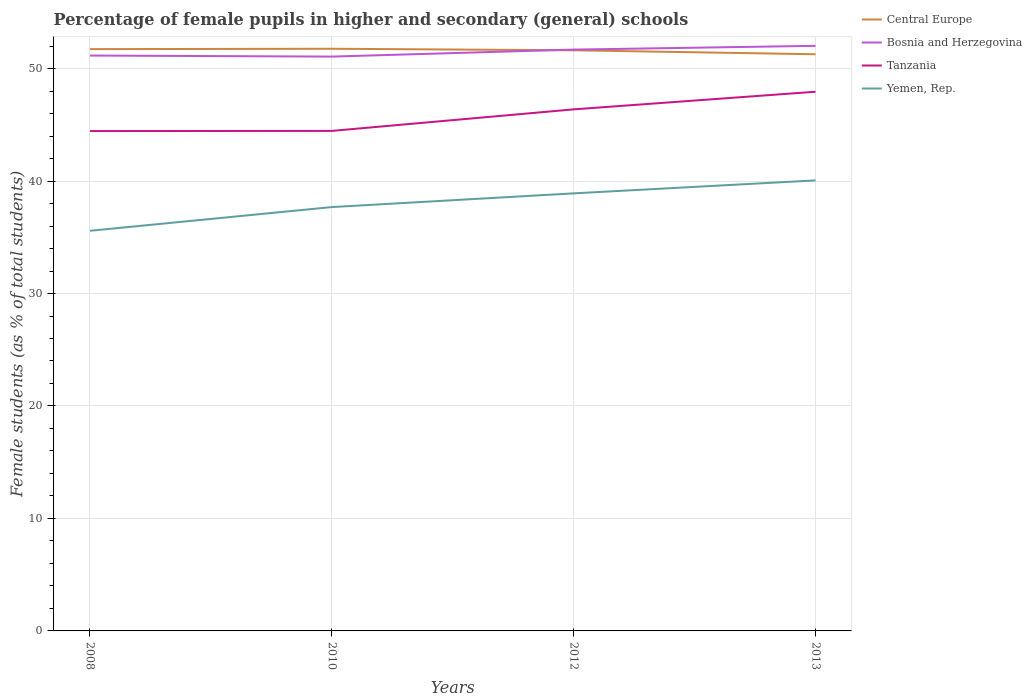How many different coloured lines are there?
Provide a short and direct response. 4. Across all years, what is the maximum percentage of female pupils in higher and secondary schools in Yemen, Rep.?
Give a very brief answer. 35.58. In which year was the percentage of female pupils in higher and secondary schools in Central Europe maximum?
Ensure brevity in your answer.  2013. What is the total percentage of female pupils in higher and secondary schools in Tanzania in the graph?
Your response must be concise. -0.01. What is the difference between the highest and the second highest percentage of female pupils in higher and secondary schools in Central Europe?
Offer a terse response. 0.49. What is the difference between the highest and the lowest percentage of female pupils in higher and secondary schools in Yemen, Rep.?
Provide a succinct answer. 2. Is the percentage of female pupils in higher and secondary schools in Bosnia and Herzegovina strictly greater than the percentage of female pupils in higher and secondary schools in Central Europe over the years?
Keep it short and to the point. No. How many years are there in the graph?
Keep it short and to the point. 4. Does the graph contain any zero values?
Your response must be concise. No. Where does the legend appear in the graph?
Your response must be concise. Top right. How are the legend labels stacked?
Offer a very short reply. Vertical. What is the title of the graph?
Keep it short and to the point. Percentage of female pupils in higher and secondary (general) schools. Does "Mali" appear as one of the legend labels in the graph?
Your response must be concise. No. What is the label or title of the Y-axis?
Your answer should be very brief. Female students (as % of total students). What is the Female students (as % of total students) of Central Europe in 2008?
Give a very brief answer. 51.73. What is the Female students (as % of total students) in Bosnia and Herzegovina in 2008?
Your answer should be very brief. 51.16. What is the Female students (as % of total students) of Tanzania in 2008?
Provide a short and direct response. 44.44. What is the Female students (as % of total students) in Yemen, Rep. in 2008?
Give a very brief answer. 35.58. What is the Female students (as % of total students) in Central Europe in 2010?
Ensure brevity in your answer.  51.76. What is the Female students (as % of total students) of Bosnia and Herzegovina in 2010?
Provide a short and direct response. 51.06. What is the Female students (as % of total students) of Tanzania in 2010?
Your answer should be compact. 44.46. What is the Female students (as % of total students) in Yemen, Rep. in 2010?
Your answer should be compact. 37.69. What is the Female students (as % of total students) in Central Europe in 2012?
Your answer should be very brief. 51.63. What is the Female students (as % of total students) in Bosnia and Herzegovina in 2012?
Ensure brevity in your answer.  51.69. What is the Female students (as % of total students) in Tanzania in 2012?
Offer a terse response. 46.37. What is the Female students (as % of total students) of Yemen, Rep. in 2012?
Provide a short and direct response. 38.9. What is the Female students (as % of total students) in Central Europe in 2013?
Ensure brevity in your answer.  51.27. What is the Female students (as % of total students) of Bosnia and Herzegovina in 2013?
Your answer should be compact. 52.02. What is the Female students (as % of total students) in Tanzania in 2013?
Keep it short and to the point. 47.94. What is the Female students (as % of total students) in Yemen, Rep. in 2013?
Your answer should be very brief. 40.06. Across all years, what is the maximum Female students (as % of total students) in Central Europe?
Your answer should be compact. 51.76. Across all years, what is the maximum Female students (as % of total students) of Bosnia and Herzegovina?
Provide a short and direct response. 52.02. Across all years, what is the maximum Female students (as % of total students) in Tanzania?
Your response must be concise. 47.94. Across all years, what is the maximum Female students (as % of total students) of Yemen, Rep.?
Provide a succinct answer. 40.06. Across all years, what is the minimum Female students (as % of total students) of Central Europe?
Provide a succinct answer. 51.27. Across all years, what is the minimum Female students (as % of total students) in Bosnia and Herzegovina?
Make the answer very short. 51.06. Across all years, what is the minimum Female students (as % of total students) of Tanzania?
Ensure brevity in your answer.  44.44. Across all years, what is the minimum Female students (as % of total students) in Yemen, Rep.?
Offer a very short reply. 35.58. What is the total Female students (as % of total students) of Central Europe in the graph?
Ensure brevity in your answer.  206.39. What is the total Female students (as % of total students) of Bosnia and Herzegovina in the graph?
Ensure brevity in your answer.  205.93. What is the total Female students (as % of total students) of Tanzania in the graph?
Your answer should be compact. 183.21. What is the total Female students (as % of total students) in Yemen, Rep. in the graph?
Make the answer very short. 152.22. What is the difference between the Female students (as % of total students) in Central Europe in 2008 and that in 2010?
Make the answer very short. -0.03. What is the difference between the Female students (as % of total students) of Bosnia and Herzegovina in 2008 and that in 2010?
Offer a terse response. 0.09. What is the difference between the Female students (as % of total students) of Tanzania in 2008 and that in 2010?
Make the answer very short. -0.01. What is the difference between the Female students (as % of total students) in Yemen, Rep. in 2008 and that in 2010?
Make the answer very short. -2.11. What is the difference between the Female students (as % of total students) in Central Europe in 2008 and that in 2012?
Keep it short and to the point. 0.1. What is the difference between the Female students (as % of total students) of Bosnia and Herzegovina in 2008 and that in 2012?
Give a very brief answer. -0.53. What is the difference between the Female students (as % of total students) in Tanzania in 2008 and that in 2012?
Offer a very short reply. -1.93. What is the difference between the Female students (as % of total students) in Yemen, Rep. in 2008 and that in 2012?
Offer a very short reply. -3.33. What is the difference between the Female students (as % of total students) of Central Europe in 2008 and that in 2013?
Your answer should be compact. 0.46. What is the difference between the Female students (as % of total students) of Bosnia and Herzegovina in 2008 and that in 2013?
Provide a succinct answer. -0.86. What is the difference between the Female students (as % of total students) of Tanzania in 2008 and that in 2013?
Provide a short and direct response. -3.5. What is the difference between the Female students (as % of total students) in Yemen, Rep. in 2008 and that in 2013?
Keep it short and to the point. -4.48. What is the difference between the Female students (as % of total students) of Central Europe in 2010 and that in 2012?
Offer a very short reply. 0.13. What is the difference between the Female students (as % of total students) in Bosnia and Herzegovina in 2010 and that in 2012?
Offer a very short reply. -0.62. What is the difference between the Female students (as % of total students) in Tanzania in 2010 and that in 2012?
Your response must be concise. -1.92. What is the difference between the Female students (as % of total students) of Yemen, Rep. in 2010 and that in 2012?
Provide a succinct answer. -1.22. What is the difference between the Female students (as % of total students) of Central Europe in 2010 and that in 2013?
Your answer should be very brief. 0.49. What is the difference between the Female students (as % of total students) in Bosnia and Herzegovina in 2010 and that in 2013?
Provide a succinct answer. -0.96. What is the difference between the Female students (as % of total students) of Tanzania in 2010 and that in 2013?
Offer a very short reply. -3.48. What is the difference between the Female students (as % of total students) of Yemen, Rep. in 2010 and that in 2013?
Your answer should be very brief. -2.37. What is the difference between the Female students (as % of total students) in Central Europe in 2012 and that in 2013?
Ensure brevity in your answer.  0.35. What is the difference between the Female students (as % of total students) in Bosnia and Herzegovina in 2012 and that in 2013?
Offer a very short reply. -0.33. What is the difference between the Female students (as % of total students) in Tanzania in 2012 and that in 2013?
Offer a terse response. -1.57. What is the difference between the Female students (as % of total students) in Yemen, Rep. in 2012 and that in 2013?
Provide a short and direct response. -1.15. What is the difference between the Female students (as % of total students) of Central Europe in 2008 and the Female students (as % of total students) of Bosnia and Herzegovina in 2010?
Your answer should be very brief. 0.66. What is the difference between the Female students (as % of total students) of Central Europe in 2008 and the Female students (as % of total students) of Tanzania in 2010?
Provide a short and direct response. 7.27. What is the difference between the Female students (as % of total students) in Central Europe in 2008 and the Female students (as % of total students) in Yemen, Rep. in 2010?
Your response must be concise. 14.04. What is the difference between the Female students (as % of total students) in Bosnia and Herzegovina in 2008 and the Female students (as % of total students) in Tanzania in 2010?
Your answer should be compact. 6.7. What is the difference between the Female students (as % of total students) of Bosnia and Herzegovina in 2008 and the Female students (as % of total students) of Yemen, Rep. in 2010?
Your answer should be very brief. 13.47. What is the difference between the Female students (as % of total students) in Tanzania in 2008 and the Female students (as % of total students) in Yemen, Rep. in 2010?
Your response must be concise. 6.76. What is the difference between the Female students (as % of total students) in Central Europe in 2008 and the Female students (as % of total students) in Bosnia and Herzegovina in 2012?
Ensure brevity in your answer.  0.04. What is the difference between the Female students (as % of total students) of Central Europe in 2008 and the Female students (as % of total students) of Tanzania in 2012?
Offer a very short reply. 5.36. What is the difference between the Female students (as % of total students) in Central Europe in 2008 and the Female students (as % of total students) in Yemen, Rep. in 2012?
Provide a succinct answer. 12.82. What is the difference between the Female students (as % of total students) in Bosnia and Herzegovina in 2008 and the Female students (as % of total students) in Tanzania in 2012?
Your response must be concise. 4.78. What is the difference between the Female students (as % of total students) of Bosnia and Herzegovina in 2008 and the Female students (as % of total students) of Yemen, Rep. in 2012?
Your answer should be very brief. 12.25. What is the difference between the Female students (as % of total students) of Tanzania in 2008 and the Female students (as % of total students) of Yemen, Rep. in 2012?
Ensure brevity in your answer.  5.54. What is the difference between the Female students (as % of total students) in Central Europe in 2008 and the Female students (as % of total students) in Bosnia and Herzegovina in 2013?
Your answer should be compact. -0.29. What is the difference between the Female students (as % of total students) in Central Europe in 2008 and the Female students (as % of total students) in Tanzania in 2013?
Offer a very short reply. 3.79. What is the difference between the Female students (as % of total students) in Central Europe in 2008 and the Female students (as % of total students) in Yemen, Rep. in 2013?
Your answer should be compact. 11.67. What is the difference between the Female students (as % of total students) in Bosnia and Herzegovina in 2008 and the Female students (as % of total students) in Tanzania in 2013?
Make the answer very short. 3.22. What is the difference between the Female students (as % of total students) of Bosnia and Herzegovina in 2008 and the Female students (as % of total students) of Yemen, Rep. in 2013?
Offer a very short reply. 11.1. What is the difference between the Female students (as % of total students) in Tanzania in 2008 and the Female students (as % of total students) in Yemen, Rep. in 2013?
Offer a very short reply. 4.39. What is the difference between the Female students (as % of total students) of Central Europe in 2010 and the Female students (as % of total students) of Bosnia and Herzegovina in 2012?
Ensure brevity in your answer.  0.07. What is the difference between the Female students (as % of total students) of Central Europe in 2010 and the Female students (as % of total students) of Tanzania in 2012?
Make the answer very short. 5.39. What is the difference between the Female students (as % of total students) in Central Europe in 2010 and the Female students (as % of total students) in Yemen, Rep. in 2012?
Ensure brevity in your answer.  12.86. What is the difference between the Female students (as % of total students) of Bosnia and Herzegovina in 2010 and the Female students (as % of total students) of Tanzania in 2012?
Provide a short and direct response. 4.69. What is the difference between the Female students (as % of total students) in Bosnia and Herzegovina in 2010 and the Female students (as % of total students) in Yemen, Rep. in 2012?
Make the answer very short. 12.16. What is the difference between the Female students (as % of total students) of Tanzania in 2010 and the Female students (as % of total students) of Yemen, Rep. in 2012?
Keep it short and to the point. 5.55. What is the difference between the Female students (as % of total students) of Central Europe in 2010 and the Female students (as % of total students) of Bosnia and Herzegovina in 2013?
Make the answer very short. -0.26. What is the difference between the Female students (as % of total students) in Central Europe in 2010 and the Female students (as % of total students) in Tanzania in 2013?
Your answer should be very brief. 3.82. What is the difference between the Female students (as % of total students) in Central Europe in 2010 and the Female students (as % of total students) in Yemen, Rep. in 2013?
Make the answer very short. 11.7. What is the difference between the Female students (as % of total students) of Bosnia and Herzegovina in 2010 and the Female students (as % of total students) of Tanzania in 2013?
Provide a succinct answer. 3.12. What is the difference between the Female students (as % of total students) in Bosnia and Herzegovina in 2010 and the Female students (as % of total students) in Yemen, Rep. in 2013?
Provide a short and direct response. 11.01. What is the difference between the Female students (as % of total students) of Central Europe in 2012 and the Female students (as % of total students) of Bosnia and Herzegovina in 2013?
Your answer should be very brief. -0.4. What is the difference between the Female students (as % of total students) in Central Europe in 2012 and the Female students (as % of total students) in Tanzania in 2013?
Offer a terse response. 3.69. What is the difference between the Female students (as % of total students) in Central Europe in 2012 and the Female students (as % of total students) in Yemen, Rep. in 2013?
Offer a very short reply. 11.57. What is the difference between the Female students (as % of total students) of Bosnia and Herzegovina in 2012 and the Female students (as % of total students) of Tanzania in 2013?
Provide a short and direct response. 3.75. What is the difference between the Female students (as % of total students) in Bosnia and Herzegovina in 2012 and the Female students (as % of total students) in Yemen, Rep. in 2013?
Keep it short and to the point. 11.63. What is the difference between the Female students (as % of total students) of Tanzania in 2012 and the Female students (as % of total students) of Yemen, Rep. in 2013?
Your response must be concise. 6.32. What is the average Female students (as % of total students) in Central Europe per year?
Make the answer very short. 51.6. What is the average Female students (as % of total students) in Bosnia and Herzegovina per year?
Give a very brief answer. 51.48. What is the average Female students (as % of total students) in Tanzania per year?
Keep it short and to the point. 45.8. What is the average Female students (as % of total students) in Yemen, Rep. per year?
Keep it short and to the point. 38.06. In the year 2008, what is the difference between the Female students (as % of total students) of Central Europe and Female students (as % of total students) of Bosnia and Herzegovina?
Your answer should be compact. 0.57. In the year 2008, what is the difference between the Female students (as % of total students) in Central Europe and Female students (as % of total students) in Tanzania?
Provide a short and direct response. 7.28. In the year 2008, what is the difference between the Female students (as % of total students) of Central Europe and Female students (as % of total students) of Yemen, Rep.?
Your response must be concise. 16.15. In the year 2008, what is the difference between the Female students (as % of total students) of Bosnia and Herzegovina and Female students (as % of total students) of Tanzania?
Offer a very short reply. 6.71. In the year 2008, what is the difference between the Female students (as % of total students) of Bosnia and Herzegovina and Female students (as % of total students) of Yemen, Rep.?
Your response must be concise. 15.58. In the year 2008, what is the difference between the Female students (as % of total students) in Tanzania and Female students (as % of total students) in Yemen, Rep.?
Keep it short and to the point. 8.87. In the year 2010, what is the difference between the Female students (as % of total students) in Central Europe and Female students (as % of total students) in Bosnia and Herzegovina?
Keep it short and to the point. 0.7. In the year 2010, what is the difference between the Female students (as % of total students) of Central Europe and Female students (as % of total students) of Tanzania?
Make the answer very short. 7.3. In the year 2010, what is the difference between the Female students (as % of total students) in Central Europe and Female students (as % of total students) in Yemen, Rep.?
Your response must be concise. 14.07. In the year 2010, what is the difference between the Female students (as % of total students) in Bosnia and Herzegovina and Female students (as % of total students) in Tanzania?
Your response must be concise. 6.61. In the year 2010, what is the difference between the Female students (as % of total students) in Bosnia and Herzegovina and Female students (as % of total students) in Yemen, Rep.?
Offer a terse response. 13.38. In the year 2010, what is the difference between the Female students (as % of total students) of Tanzania and Female students (as % of total students) of Yemen, Rep.?
Provide a succinct answer. 6.77. In the year 2012, what is the difference between the Female students (as % of total students) of Central Europe and Female students (as % of total students) of Bosnia and Herzegovina?
Give a very brief answer. -0.06. In the year 2012, what is the difference between the Female students (as % of total students) in Central Europe and Female students (as % of total students) in Tanzania?
Offer a terse response. 5.25. In the year 2012, what is the difference between the Female students (as % of total students) of Central Europe and Female students (as % of total students) of Yemen, Rep.?
Keep it short and to the point. 12.72. In the year 2012, what is the difference between the Female students (as % of total students) in Bosnia and Herzegovina and Female students (as % of total students) in Tanzania?
Offer a terse response. 5.31. In the year 2012, what is the difference between the Female students (as % of total students) in Bosnia and Herzegovina and Female students (as % of total students) in Yemen, Rep.?
Offer a very short reply. 12.78. In the year 2012, what is the difference between the Female students (as % of total students) of Tanzania and Female students (as % of total students) of Yemen, Rep.?
Make the answer very short. 7.47. In the year 2013, what is the difference between the Female students (as % of total students) of Central Europe and Female students (as % of total students) of Bosnia and Herzegovina?
Offer a very short reply. -0.75. In the year 2013, what is the difference between the Female students (as % of total students) in Central Europe and Female students (as % of total students) in Tanzania?
Provide a succinct answer. 3.33. In the year 2013, what is the difference between the Female students (as % of total students) of Central Europe and Female students (as % of total students) of Yemen, Rep.?
Your answer should be very brief. 11.21. In the year 2013, what is the difference between the Female students (as % of total students) in Bosnia and Herzegovina and Female students (as % of total students) in Tanzania?
Offer a very short reply. 4.08. In the year 2013, what is the difference between the Female students (as % of total students) in Bosnia and Herzegovina and Female students (as % of total students) in Yemen, Rep.?
Offer a terse response. 11.96. In the year 2013, what is the difference between the Female students (as % of total students) of Tanzania and Female students (as % of total students) of Yemen, Rep.?
Offer a very short reply. 7.88. What is the ratio of the Female students (as % of total students) in Tanzania in 2008 to that in 2010?
Ensure brevity in your answer.  1. What is the ratio of the Female students (as % of total students) in Yemen, Rep. in 2008 to that in 2010?
Offer a terse response. 0.94. What is the ratio of the Female students (as % of total students) of Tanzania in 2008 to that in 2012?
Your response must be concise. 0.96. What is the ratio of the Female students (as % of total students) of Yemen, Rep. in 2008 to that in 2012?
Keep it short and to the point. 0.91. What is the ratio of the Female students (as % of total students) in Central Europe in 2008 to that in 2013?
Provide a succinct answer. 1.01. What is the ratio of the Female students (as % of total students) in Bosnia and Herzegovina in 2008 to that in 2013?
Provide a short and direct response. 0.98. What is the ratio of the Female students (as % of total students) of Tanzania in 2008 to that in 2013?
Your answer should be compact. 0.93. What is the ratio of the Female students (as % of total students) in Yemen, Rep. in 2008 to that in 2013?
Make the answer very short. 0.89. What is the ratio of the Female students (as % of total students) of Bosnia and Herzegovina in 2010 to that in 2012?
Give a very brief answer. 0.99. What is the ratio of the Female students (as % of total students) of Tanzania in 2010 to that in 2012?
Your answer should be compact. 0.96. What is the ratio of the Female students (as % of total students) of Yemen, Rep. in 2010 to that in 2012?
Provide a short and direct response. 0.97. What is the ratio of the Female students (as % of total students) in Central Europe in 2010 to that in 2013?
Offer a very short reply. 1.01. What is the ratio of the Female students (as % of total students) of Bosnia and Herzegovina in 2010 to that in 2013?
Give a very brief answer. 0.98. What is the ratio of the Female students (as % of total students) of Tanzania in 2010 to that in 2013?
Ensure brevity in your answer.  0.93. What is the ratio of the Female students (as % of total students) of Yemen, Rep. in 2010 to that in 2013?
Keep it short and to the point. 0.94. What is the ratio of the Female students (as % of total students) of Tanzania in 2012 to that in 2013?
Give a very brief answer. 0.97. What is the ratio of the Female students (as % of total students) in Yemen, Rep. in 2012 to that in 2013?
Ensure brevity in your answer.  0.97. What is the difference between the highest and the second highest Female students (as % of total students) in Central Europe?
Provide a succinct answer. 0.03. What is the difference between the highest and the second highest Female students (as % of total students) in Bosnia and Herzegovina?
Your response must be concise. 0.33. What is the difference between the highest and the second highest Female students (as % of total students) of Tanzania?
Provide a succinct answer. 1.57. What is the difference between the highest and the second highest Female students (as % of total students) in Yemen, Rep.?
Make the answer very short. 1.15. What is the difference between the highest and the lowest Female students (as % of total students) in Central Europe?
Your response must be concise. 0.49. What is the difference between the highest and the lowest Female students (as % of total students) in Bosnia and Herzegovina?
Provide a short and direct response. 0.96. What is the difference between the highest and the lowest Female students (as % of total students) of Tanzania?
Your response must be concise. 3.5. What is the difference between the highest and the lowest Female students (as % of total students) in Yemen, Rep.?
Your answer should be compact. 4.48. 